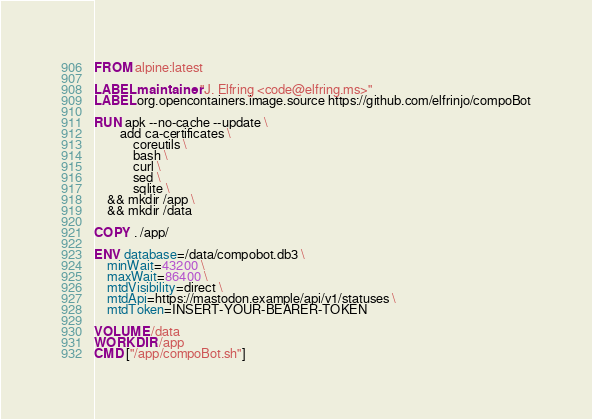<code> <loc_0><loc_0><loc_500><loc_500><_Dockerfile_>FROM alpine:latest

LABEL maintainer "J. Elfring <code@elfring.ms>"
LABEL org.opencontainers.image.source https://github.com/elfrinjo/compoBot

RUN apk --no-cache --update \
        add ca-certificates \
            coreutils \
            bash \
            curl \
            sed \
            sqlite \
    && mkdir /app \
    && mkdir /data

COPY . /app/

ENV database=/data/compobot.db3 \
    minWait=43200 \
    maxWait=86400 \
    mtdVisibility=direct \
    mtdApi=https://mastodon.example/api/v1/statuses \
    mtdToken=INSERT-YOUR-BEARER-TOKEN

VOLUME /data
WORKDIR /app
CMD ["/app/compoBot.sh"]
</code> 